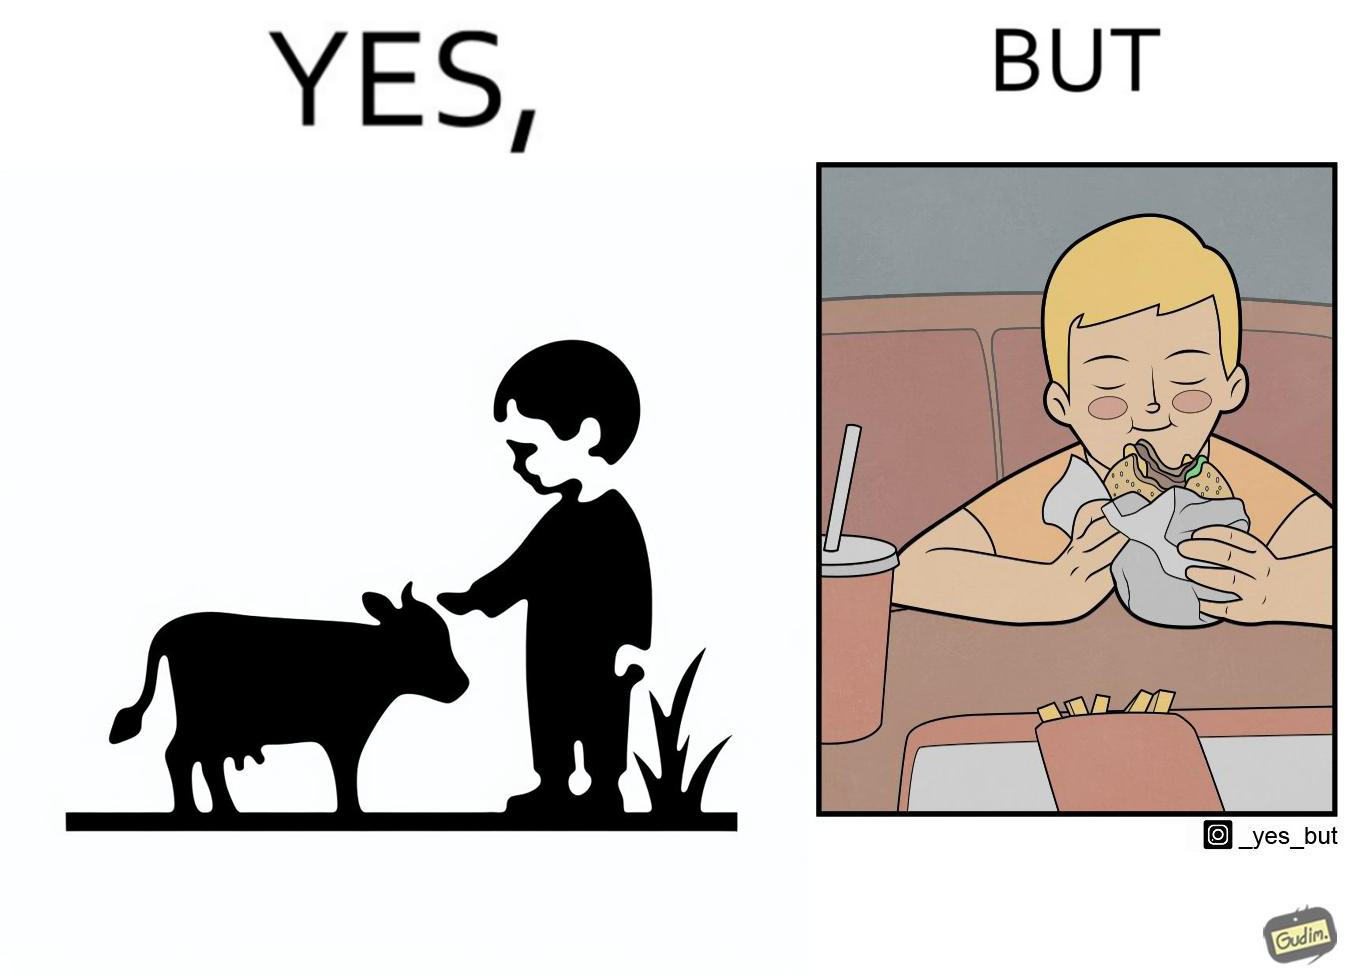What do you see in each half of this image? In the left part of the image: A boy petting a cow In the right part of the image: A boy eating a hamburger 